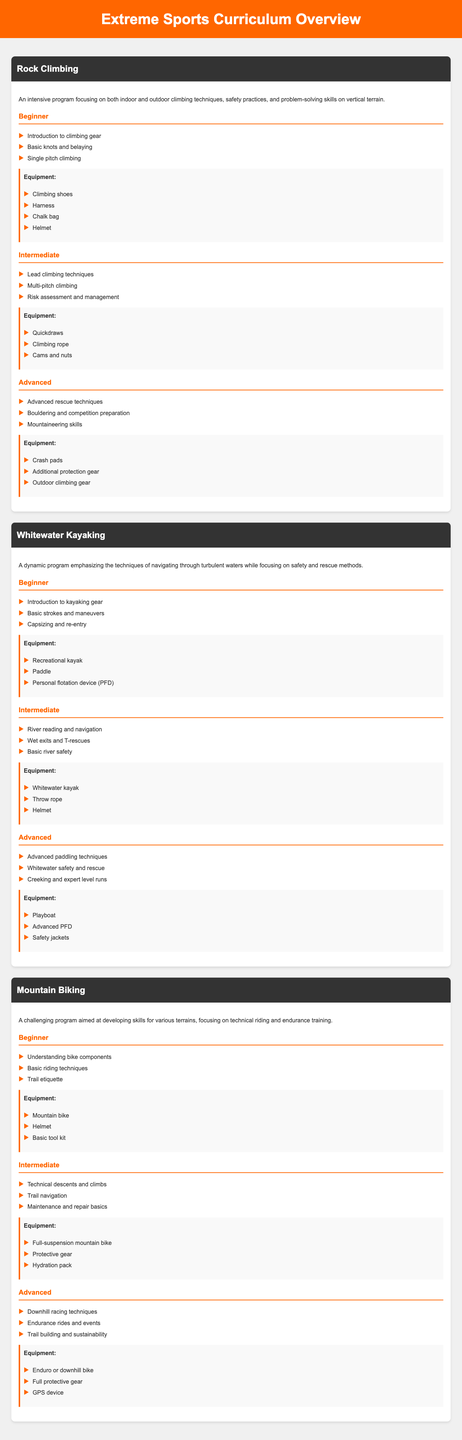What sports are included in the curriculum overview? The curriculum overview includes Rock Climbing, Whitewater Kayaking, and Mountain Biking, as stated in the document.
Answer: Rock Climbing, Whitewater Kayaking, Mountain Biking How many skill levels are there for each sport? Each sport has three skill levels: Beginner, Intermediate, and Advanced, as highlighted in the course descriptions.
Answer: Three What kind of equipment is required for beginner rock climbing? The document specifies a list of equipment needed for beginner rock climbing, including climbing shoes, harness, chalk bag, and helmet.
Answer: Climbing shoes, harness, chalk bag, helmet Which skill level teaches advanced rescue techniques in rock climbing? The document outlines that advanced rescue techniques are part of the Advanced skill level in rock climbing.
Answer: Advanced What is one of the techniques taught at the intermediate level of whitewater kayaking? According to the document, the intermediate level includes learning river reading and navigation.
Answer: River reading and navigation What type of bike is needed for advanced mountain biking? The equipment list for advanced mountain biking specifies the need for an Enduro or downhill bike.
Answer: Enduro or downhill bike What safety item is required for all levels of whitewater kayaking? The document indicates that a Personal flotation device (PFD) is necessary for every level of whitewater kayaking.
Answer: Personal flotation device (PFD) What skill is emphasized in the beginner level of mountain biking? The document states that basic riding techniques are taught at the beginner level of mountain biking.
Answer: Basic riding techniques 